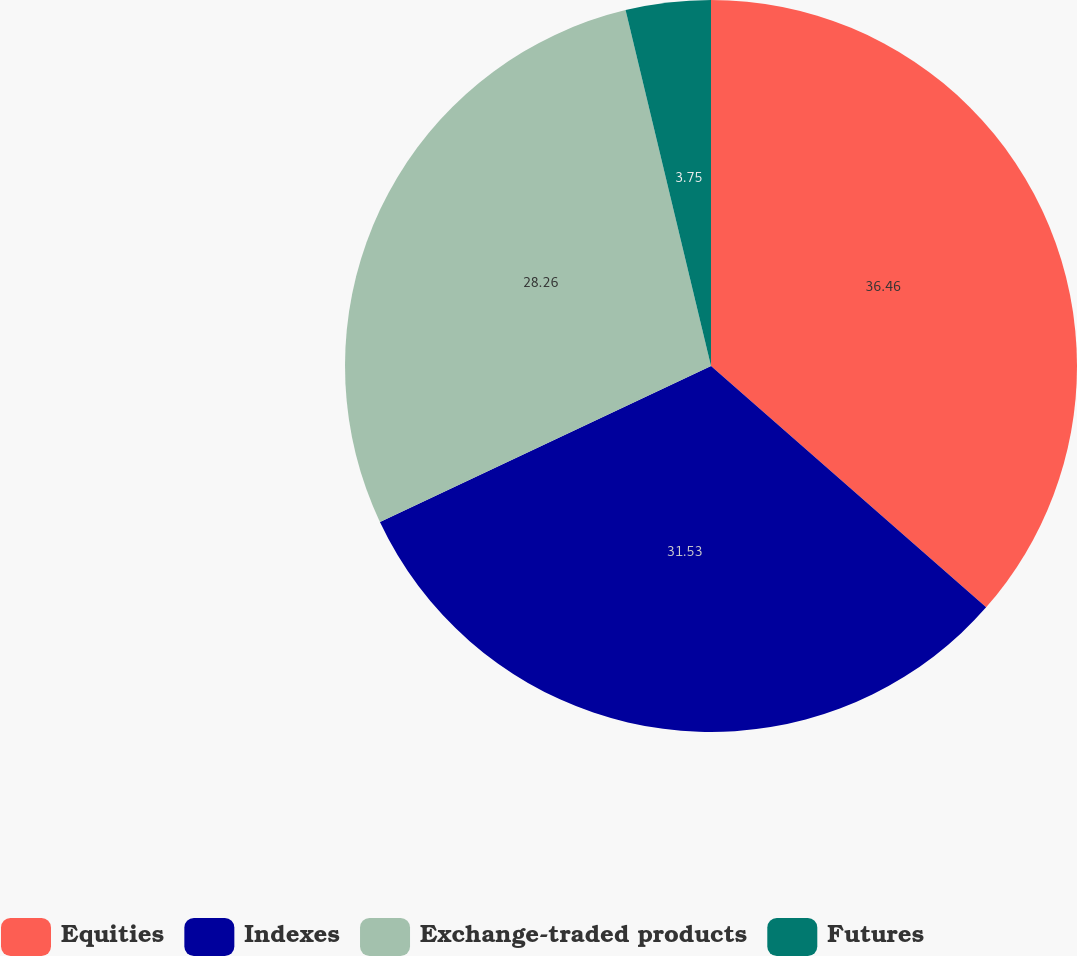Convert chart. <chart><loc_0><loc_0><loc_500><loc_500><pie_chart><fcel>Equities<fcel>Indexes<fcel>Exchange-traded products<fcel>Futures<nl><fcel>36.46%<fcel>31.53%<fcel>28.26%<fcel>3.75%<nl></chart> 